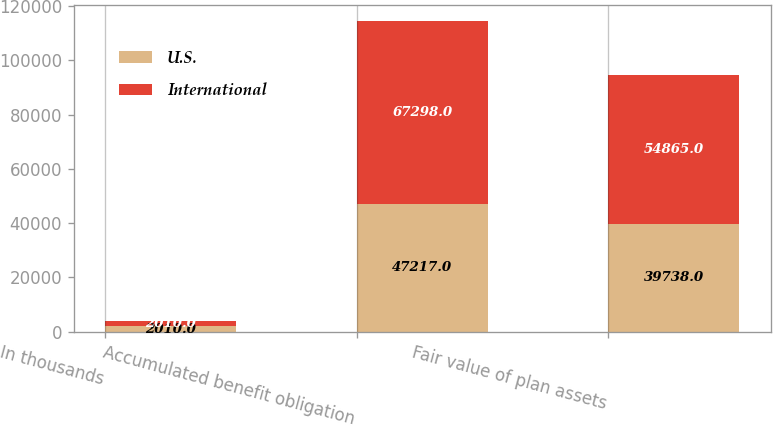<chart> <loc_0><loc_0><loc_500><loc_500><stacked_bar_chart><ecel><fcel>In thousands<fcel>Accumulated benefit obligation<fcel>Fair value of plan assets<nl><fcel>U.S.<fcel>2010<fcel>47217<fcel>39738<nl><fcel>International<fcel>2010<fcel>67298<fcel>54865<nl></chart> 